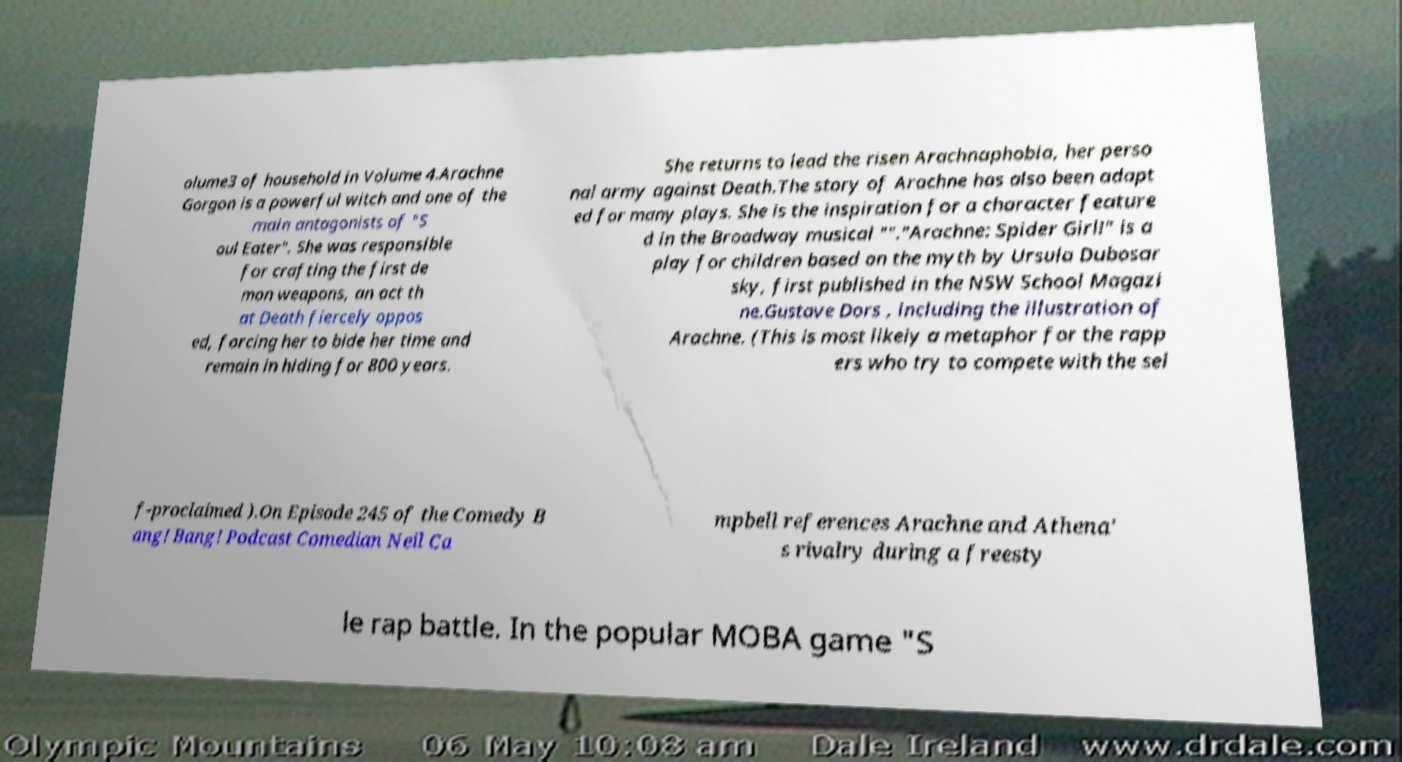For documentation purposes, I need the text within this image transcribed. Could you provide that? olume3 of household in Volume 4.Arachne Gorgon is a powerful witch and one of the main antagonists of "S oul Eater". She was responsible for crafting the first de mon weapons, an act th at Death fiercely oppos ed, forcing her to bide her time and remain in hiding for 800 years. She returns to lead the risen Arachnaphobia, her perso nal army against Death.The story of Arachne has also been adapt ed for many plays. She is the inspiration for a character feature d in the Broadway musical ""."Arachne: Spider Girl!" is a play for children based on the myth by Ursula Dubosar sky, first published in the NSW School Magazi ne.Gustave Dors , including the illustration of Arachne. (This is most likely a metaphor for the rapp ers who try to compete with the sel f-proclaimed ).On Episode 245 of the Comedy B ang! Bang! Podcast Comedian Neil Ca mpbell references Arachne and Athena' s rivalry during a freesty le rap battle. In the popular MOBA game "S 